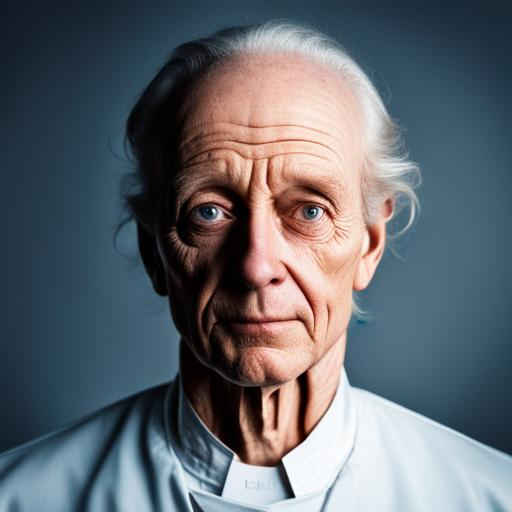Can you describe the lighting used in this photograph? The lighting in the photograph is dramatic and focused, with a soft but definitive shadow on one side of the face, showcasing the contours and features vividly. 